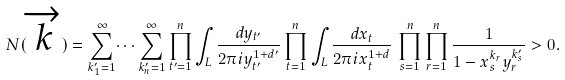Convert formula to latex. <formula><loc_0><loc_0><loc_500><loc_500>N ( \overrightarrow { k } ) = \sum _ { k ^ { \prime } _ { 1 } = 1 } ^ { \infty } \dots \sum _ { k ^ { \prime } _ { n } = 1 } ^ { \infty } \prod _ { t ^ { \prime } = 1 } ^ { n } \int _ { L } \frac { d y _ { t ^ { \prime } } } { 2 \pi i y _ { t ^ { \prime } } ^ { 1 + d ^ { \prime } } } \prod _ { t = 1 } ^ { n } \int _ { L } \frac { d x _ { t } } { 2 \pi i x _ { t } ^ { 1 + d } } \, \prod _ { s = 1 } ^ { n } \prod _ { r = 1 } ^ { n } \frac { 1 } { 1 - x _ { s } ^ { k _ { r } } y _ { r } ^ { k ^ { \prime } _ { s } } } > 0 .</formula> 